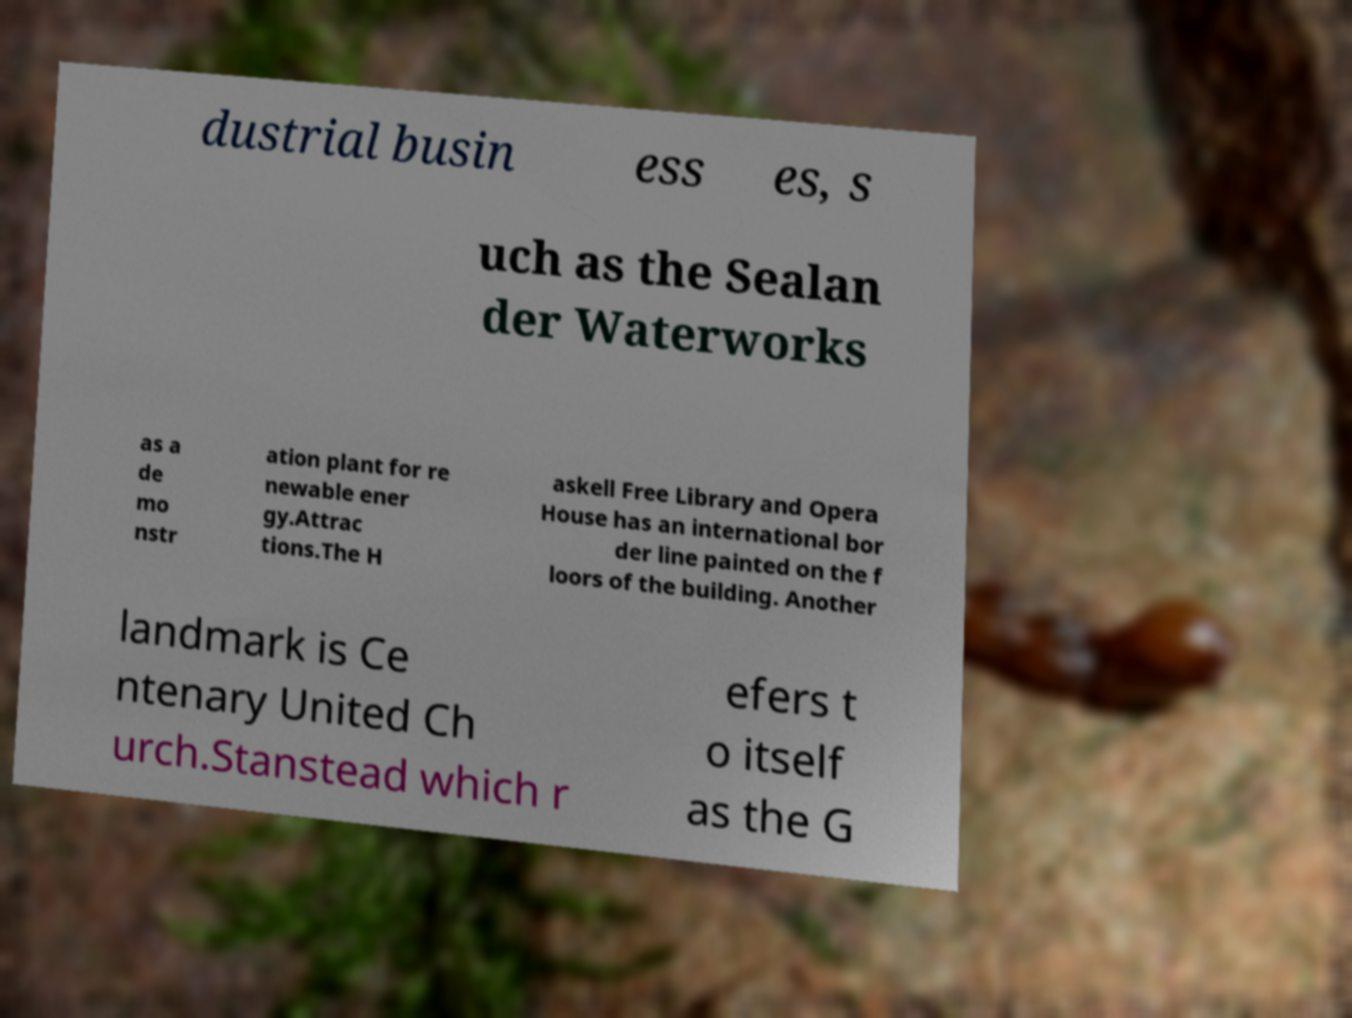I need the written content from this picture converted into text. Can you do that? dustrial busin ess es, s uch as the Sealan der Waterworks as a de mo nstr ation plant for re newable ener gy.Attrac tions.The H askell Free Library and Opera House has an international bor der line painted on the f loors of the building. Another landmark is Ce ntenary United Ch urch.Stanstead which r efers t o itself as the G 